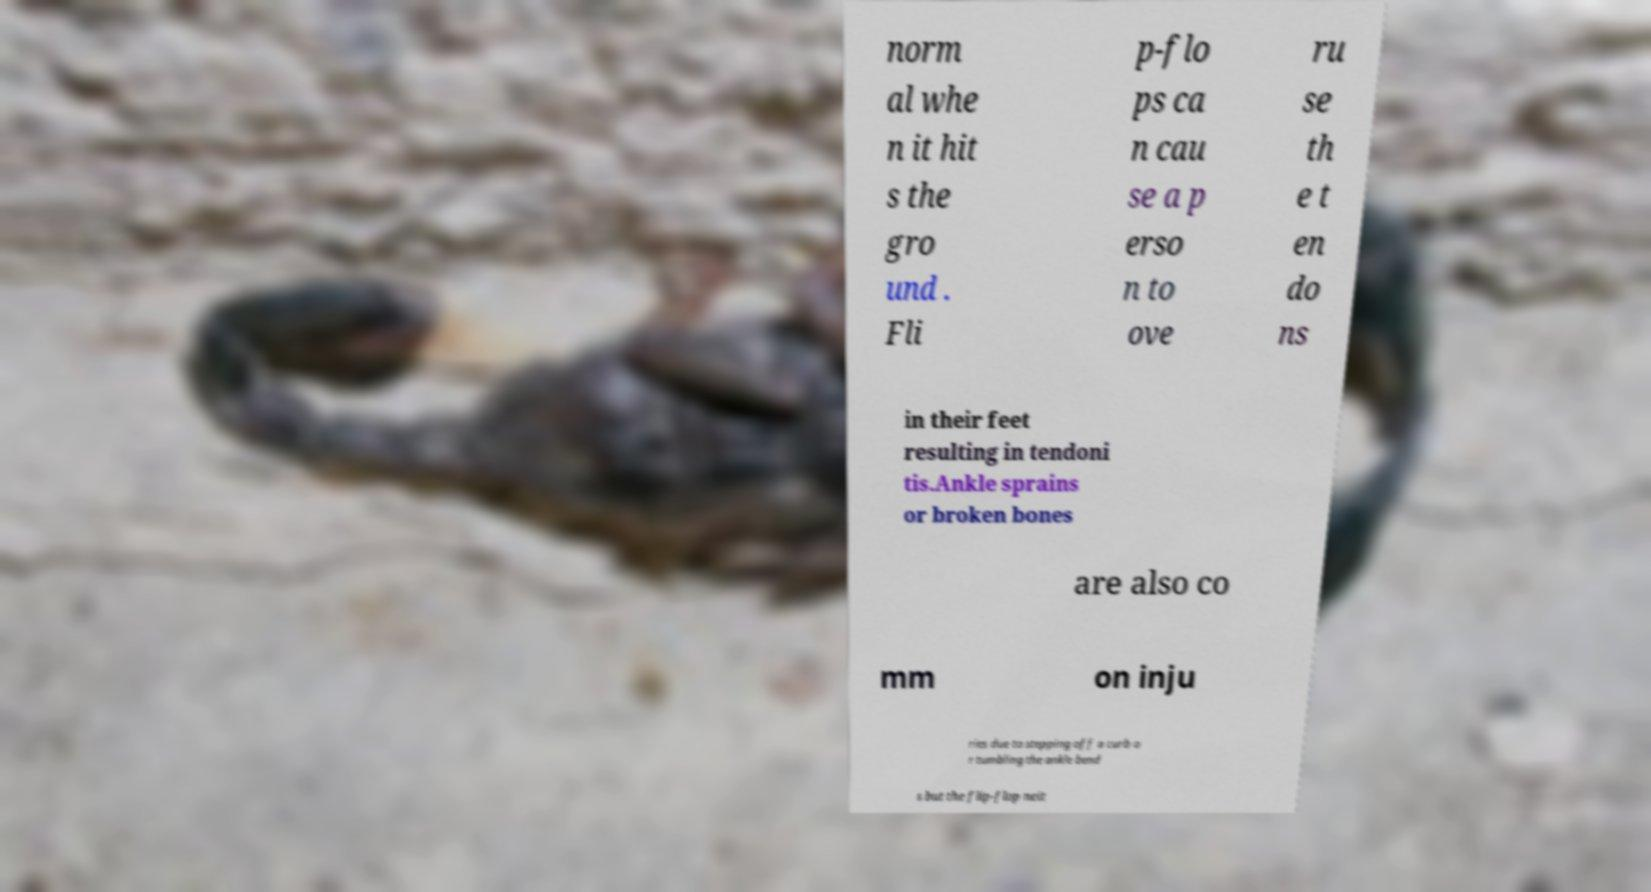Could you assist in decoding the text presented in this image and type it out clearly? norm al whe n it hit s the gro und . Fli p-flo ps ca n cau se a p erso n to ove ru se th e t en do ns in their feet resulting in tendoni tis.Ankle sprains or broken bones are also co mm on inju ries due to stepping off a curb o r tumbling the ankle bend s but the flip-flop neit 